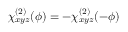Convert formula to latex. <formula><loc_0><loc_0><loc_500><loc_500>\chi _ { x y z } ^ { ( 2 ) } ( \phi ) = - \chi _ { x y z } ^ { ( 2 ) } ( - \phi )</formula> 